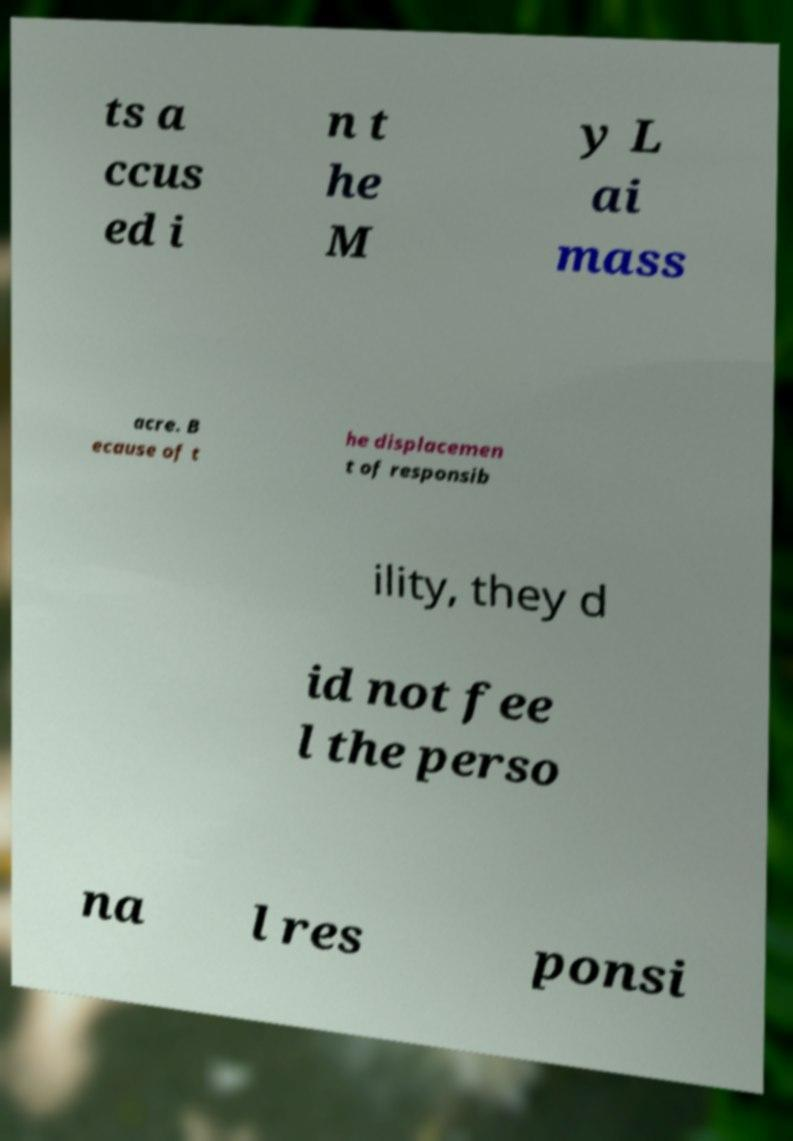Could you extract and type out the text from this image? ts a ccus ed i n t he M y L ai mass acre. B ecause of t he displacemen t of responsib ility, they d id not fee l the perso na l res ponsi 